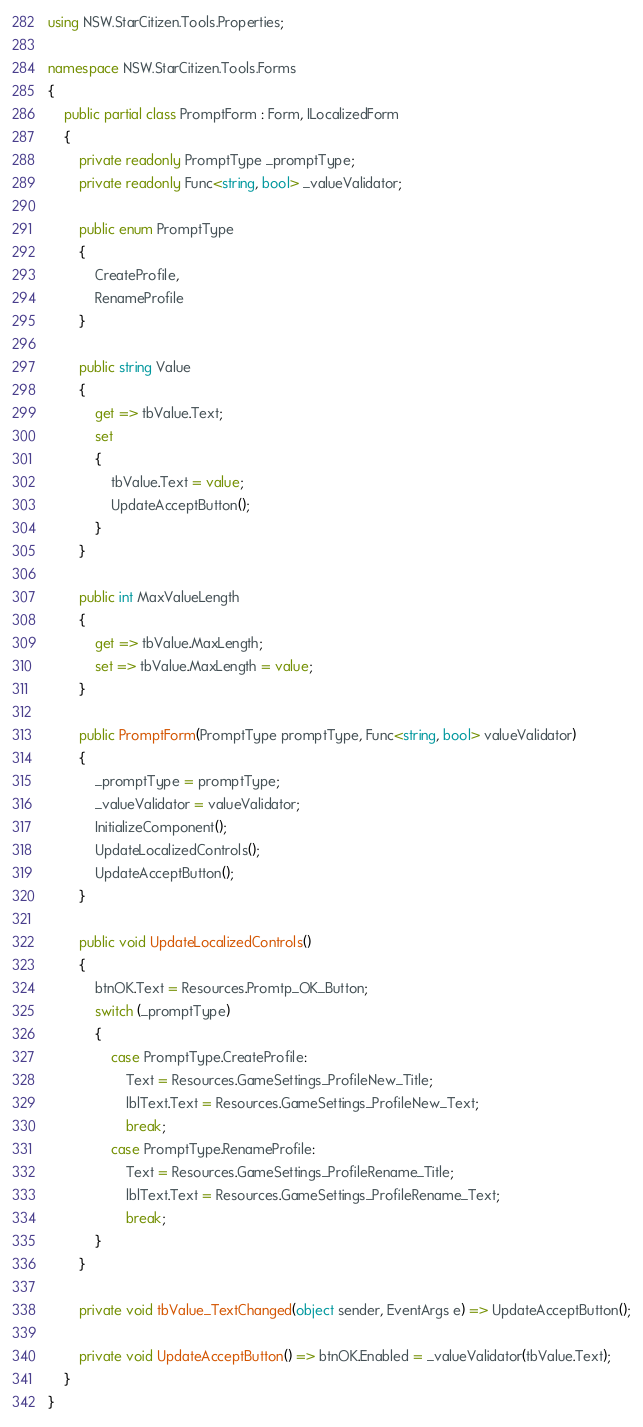Convert code to text. <code><loc_0><loc_0><loc_500><loc_500><_C#_>using NSW.StarCitizen.Tools.Properties;

namespace NSW.StarCitizen.Tools.Forms
{
    public partial class PromptForm : Form, ILocalizedForm
    {
        private readonly PromptType _promptType;
        private readonly Func<string, bool> _valueValidator;

        public enum PromptType
        {
            CreateProfile,
            RenameProfile
        }

        public string Value
        {
            get => tbValue.Text;
            set
            {
                tbValue.Text = value;
                UpdateAcceptButton();
            }
        }

        public int MaxValueLength
        {
            get => tbValue.MaxLength;
            set => tbValue.MaxLength = value;
        }

        public PromptForm(PromptType promptType, Func<string, bool> valueValidator)
        {
            _promptType = promptType;
            _valueValidator = valueValidator;
            InitializeComponent();
            UpdateLocalizedControls();
            UpdateAcceptButton();
        }

        public void UpdateLocalizedControls()
        {
            btnOK.Text = Resources.Promtp_OK_Button;
            switch (_promptType)
            {
                case PromptType.CreateProfile:
                    Text = Resources.GameSettings_ProfileNew_Title;
                    lblText.Text = Resources.GameSettings_ProfileNew_Text;
                    break;
                case PromptType.RenameProfile:
                    Text = Resources.GameSettings_ProfileRename_Title;
                    lblText.Text = Resources.GameSettings_ProfileRename_Text;
                    break;
            }
        }

        private void tbValue_TextChanged(object sender, EventArgs e) => UpdateAcceptButton();

        private void UpdateAcceptButton() => btnOK.Enabled = _valueValidator(tbValue.Text);
    }
}
</code> 